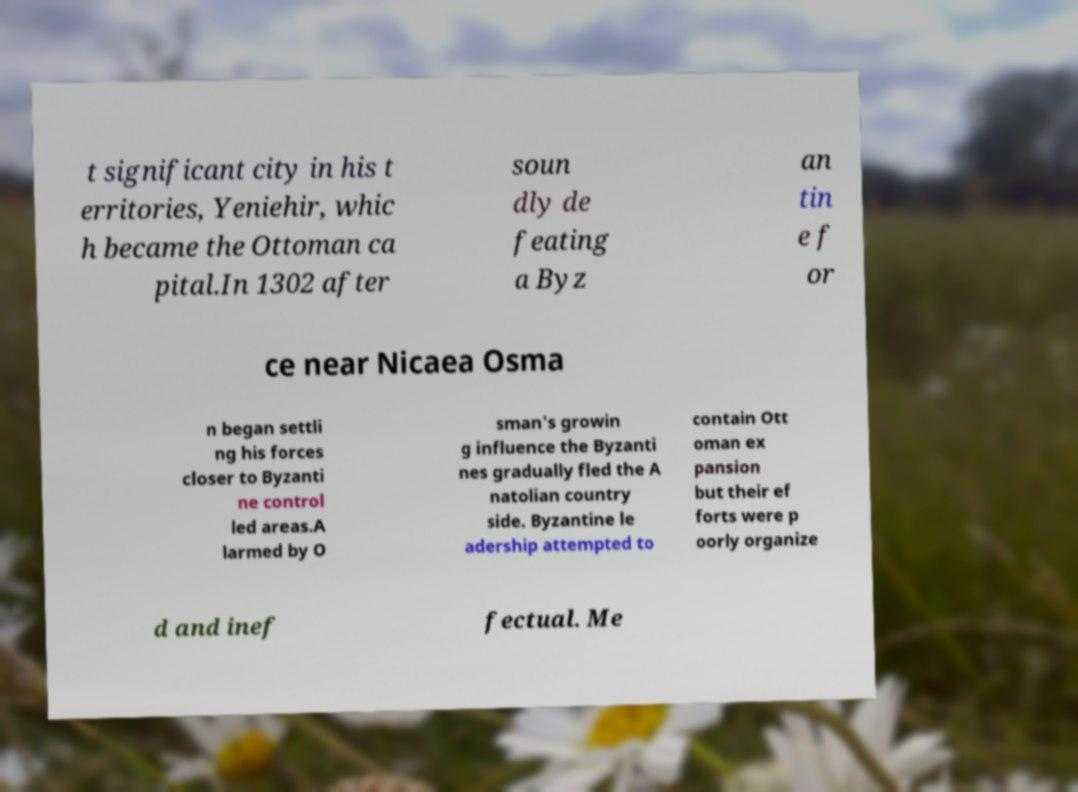Could you assist in decoding the text presented in this image and type it out clearly? The text from the image seems to provide a historical account. Here's a clearer transcription: 't significant city in his territories, Yeniehir, which became the Ottoman capital. In 1302 after soundly defeating a Byzantine force near Nicaea, Osman began settling his forces closer to Byzantine controlled areas. Alarmed by Osman's growing influence the Byzantines gradually fled the Anatolian countryside. Byzantine leadership attempted to contain Ottoman expansion, but their efforts were poorly organized and ineffectual. Me' 